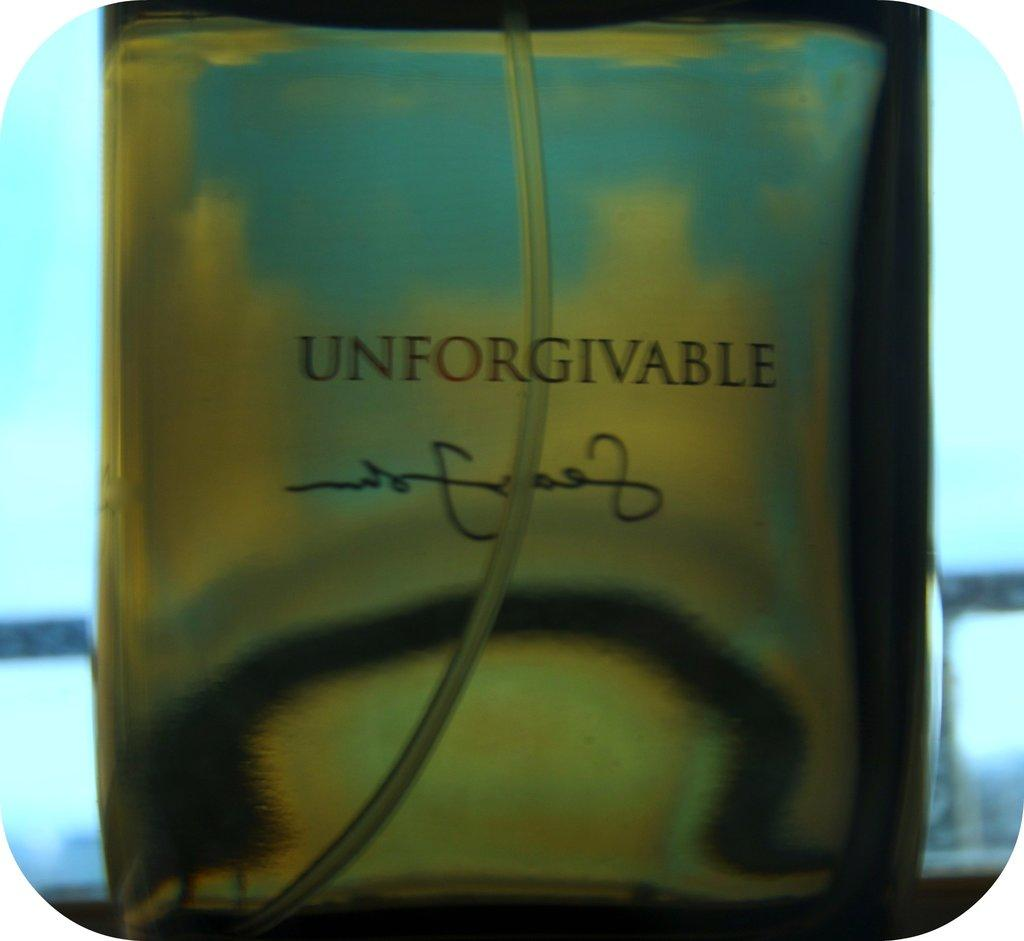<image>
Render a clear and concise summary of the photo. A bottle of UNFORGIVABLE fragrance is shown close-up. 